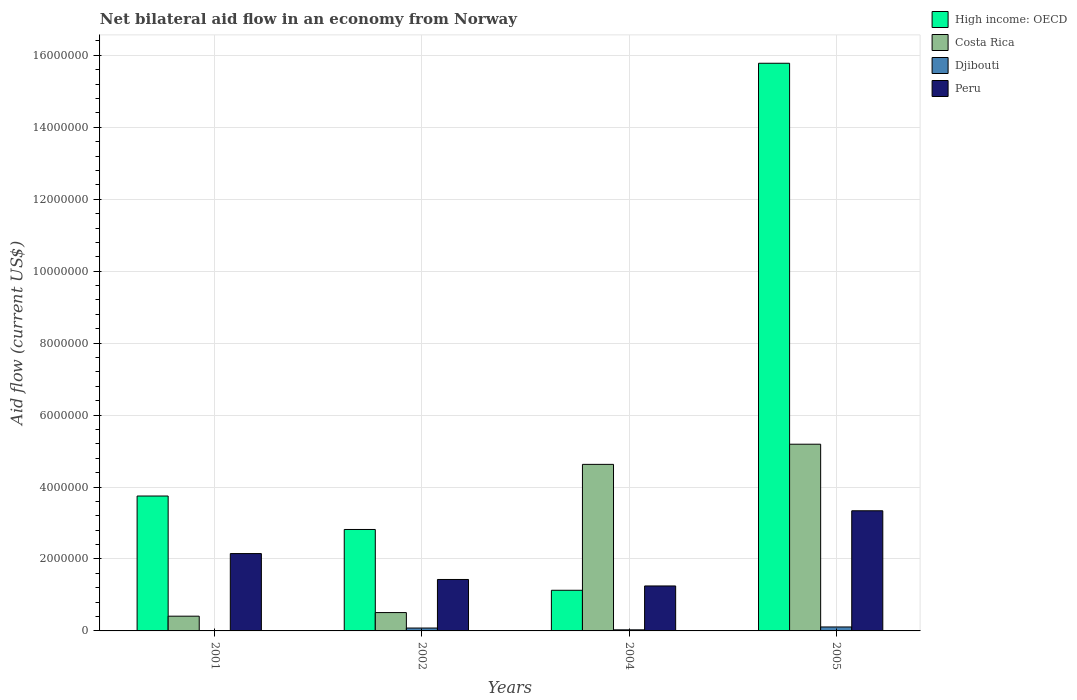How many different coloured bars are there?
Keep it short and to the point. 4. Are the number of bars per tick equal to the number of legend labels?
Offer a terse response. Yes. Are the number of bars on each tick of the X-axis equal?
Give a very brief answer. Yes. What is the label of the 1st group of bars from the left?
Ensure brevity in your answer.  2001. In how many cases, is the number of bars for a given year not equal to the number of legend labels?
Keep it short and to the point. 0. What is the net bilateral aid flow in Costa Rica in 2004?
Offer a very short reply. 4.63e+06. Across all years, what is the maximum net bilateral aid flow in Peru?
Ensure brevity in your answer.  3.34e+06. Across all years, what is the minimum net bilateral aid flow in Peru?
Give a very brief answer. 1.25e+06. In which year was the net bilateral aid flow in Djibouti minimum?
Your answer should be very brief. 2001. What is the total net bilateral aid flow in Peru in the graph?
Provide a short and direct response. 8.17e+06. What is the difference between the net bilateral aid flow in Peru in 2001 and that in 2005?
Offer a terse response. -1.19e+06. What is the difference between the net bilateral aid flow in Costa Rica in 2001 and the net bilateral aid flow in Peru in 2004?
Your response must be concise. -8.40e+05. What is the average net bilateral aid flow in Djibouti per year?
Give a very brief answer. 5.75e+04. In the year 2001, what is the difference between the net bilateral aid flow in Peru and net bilateral aid flow in High income: OECD?
Your answer should be very brief. -1.60e+06. What is the ratio of the net bilateral aid flow in Costa Rica in 2002 to that in 2004?
Ensure brevity in your answer.  0.11. Is the net bilateral aid flow in Peru in 2002 less than that in 2004?
Ensure brevity in your answer.  No. Is the difference between the net bilateral aid flow in Peru in 2001 and 2004 greater than the difference between the net bilateral aid flow in High income: OECD in 2001 and 2004?
Provide a short and direct response. No. What is the difference between the highest and the second highest net bilateral aid flow in High income: OECD?
Offer a very short reply. 1.20e+07. What is the difference between the highest and the lowest net bilateral aid flow in Costa Rica?
Keep it short and to the point. 4.78e+06. In how many years, is the net bilateral aid flow in Peru greater than the average net bilateral aid flow in Peru taken over all years?
Provide a short and direct response. 2. Is the sum of the net bilateral aid flow in High income: OECD in 2001 and 2002 greater than the maximum net bilateral aid flow in Djibouti across all years?
Offer a terse response. Yes. What does the 1st bar from the left in 2005 represents?
Give a very brief answer. High income: OECD. What does the 4th bar from the right in 2002 represents?
Your answer should be very brief. High income: OECD. Is it the case that in every year, the sum of the net bilateral aid flow in Peru and net bilateral aid flow in High income: OECD is greater than the net bilateral aid flow in Costa Rica?
Give a very brief answer. No. How many bars are there?
Make the answer very short. 16. How many years are there in the graph?
Your answer should be very brief. 4. Does the graph contain any zero values?
Provide a succinct answer. No. Does the graph contain grids?
Keep it short and to the point. Yes. Where does the legend appear in the graph?
Offer a very short reply. Top right. How many legend labels are there?
Make the answer very short. 4. How are the legend labels stacked?
Your response must be concise. Vertical. What is the title of the graph?
Provide a short and direct response. Net bilateral aid flow in an economy from Norway. What is the label or title of the X-axis?
Provide a short and direct response. Years. What is the label or title of the Y-axis?
Give a very brief answer. Aid flow (current US$). What is the Aid flow (current US$) in High income: OECD in 2001?
Ensure brevity in your answer.  3.75e+06. What is the Aid flow (current US$) in Peru in 2001?
Your answer should be compact. 2.15e+06. What is the Aid flow (current US$) in High income: OECD in 2002?
Your answer should be compact. 2.82e+06. What is the Aid flow (current US$) of Costa Rica in 2002?
Offer a terse response. 5.10e+05. What is the Aid flow (current US$) of Peru in 2002?
Offer a terse response. 1.43e+06. What is the Aid flow (current US$) of High income: OECD in 2004?
Your answer should be very brief. 1.13e+06. What is the Aid flow (current US$) in Costa Rica in 2004?
Provide a short and direct response. 4.63e+06. What is the Aid flow (current US$) of Djibouti in 2004?
Provide a short and direct response. 3.00e+04. What is the Aid flow (current US$) of Peru in 2004?
Provide a short and direct response. 1.25e+06. What is the Aid flow (current US$) of High income: OECD in 2005?
Offer a very short reply. 1.58e+07. What is the Aid flow (current US$) in Costa Rica in 2005?
Ensure brevity in your answer.  5.19e+06. What is the Aid flow (current US$) of Djibouti in 2005?
Keep it short and to the point. 1.10e+05. What is the Aid flow (current US$) of Peru in 2005?
Give a very brief answer. 3.34e+06. Across all years, what is the maximum Aid flow (current US$) of High income: OECD?
Offer a very short reply. 1.58e+07. Across all years, what is the maximum Aid flow (current US$) of Costa Rica?
Your answer should be very brief. 5.19e+06. Across all years, what is the maximum Aid flow (current US$) in Djibouti?
Ensure brevity in your answer.  1.10e+05. Across all years, what is the maximum Aid flow (current US$) of Peru?
Keep it short and to the point. 3.34e+06. Across all years, what is the minimum Aid flow (current US$) of High income: OECD?
Ensure brevity in your answer.  1.13e+06. Across all years, what is the minimum Aid flow (current US$) of Costa Rica?
Keep it short and to the point. 4.10e+05. Across all years, what is the minimum Aid flow (current US$) of Peru?
Your answer should be compact. 1.25e+06. What is the total Aid flow (current US$) in High income: OECD in the graph?
Keep it short and to the point. 2.35e+07. What is the total Aid flow (current US$) in Costa Rica in the graph?
Ensure brevity in your answer.  1.07e+07. What is the total Aid flow (current US$) in Djibouti in the graph?
Your answer should be very brief. 2.30e+05. What is the total Aid flow (current US$) in Peru in the graph?
Provide a succinct answer. 8.17e+06. What is the difference between the Aid flow (current US$) of High income: OECD in 2001 and that in 2002?
Ensure brevity in your answer.  9.30e+05. What is the difference between the Aid flow (current US$) of Costa Rica in 2001 and that in 2002?
Provide a succinct answer. -1.00e+05. What is the difference between the Aid flow (current US$) of Peru in 2001 and that in 2002?
Keep it short and to the point. 7.20e+05. What is the difference between the Aid flow (current US$) of High income: OECD in 2001 and that in 2004?
Keep it short and to the point. 2.62e+06. What is the difference between the Aid flow (current US$) of Costa Rica in 2001 and that in 2004?
Offer a very short reply. -4.22e+06. What is the difference between the Aid flow (current US$) in Peru in 2001 and that in 2004?
Ensure brevity in your answer.  9.00e+05. What is the difference between the Aid flow (current US$) in High income: OECD in 2001 and that in 2005?
Ensure brevity in your answer.  -1.20e+07. What is the difference between the Aid flow (current US$) of Costa Rica in 2001 and that in 2005?
Ensure brevity in your answer.  -4.78e+06. What is the difference between the Aid flow (current US$) in Djibouti in 2001 and that in 2005?
Offer a very short reply. -1.00e+05. What is the difference between the Aid flow (current US$) in Peru in 2001 and that in 2005?
Provide a short and direct response. -1.19e+06. What is the difference between the Aid flow (current US$) of High income: OECD in 2002 and that in 2004?
Provide a succinct answer. 1.69e+06. What is the difference between the Aid flow (current US$) of Costa Rica in 2002 and that in 2004?
Keep it short and to the point. -4.12e+06. What is the difference between the Aid flow (current US$) of Peru in 2002 and that in 2004?
Offer a very short reply. 1.80e+05. What is the difference between the Aid flow (current US$) in High income: OECD in 2002 and that in 2005?
Ensure brevity in your answer.  -1.30e+07. What is the difference between the Aid flow (current US$) of Costa Rica in 2002 and that in 2005?
Provide a succinct answer. -4.68e+06. What is the difference between the Aid flow (current US$) in Djibouti in 2002 and that in 2005?
Give a very brief answer. -3.00e+04. What is the difference between the Aid flow (current US$) of Peru in 2002 and that in 2005?
Your answer should be very brief. -1.91e+06. What is the difference between the Aid flow (current US$) of High income: OECD in 2004 and that in 2005?
Your response must be concise. -1.46e+07. What is the difference between the Aid flow (current US$) in Costa Rica in 2004 and that in 2005?
Your response must be concise. -5.60e+05. What is the difference between the Aid flow (current US$) of Peru in 2004 and that in 2005?
Offer a very short reply. -2.09e+06. What is the difference between the Aid flow (current US$) of High income: OECD in 2001 and the Aid flow (current US$) of Costa Rica in 2002?
Your answer should be compact. 3.24e+06. What is the difference between the Aid flow (current US$) of High income: OECD in 2001 and the Aid flow (current US$) of Djibouti in 2002?
Provide a succinct answer. 3.67e+06. What is the difference between the Aid flow (current US$) of High income: OECD in 2001 and the Aid flow (current US$) of Peru in 2002?
Offer a very short reply. 2.32e+06. What is the difference between the Aid flow (current US$) of Costa Rica in 2001 and the Aid flow (current US$) of Peru in 2002?
Keep it short and to the point. -1.02e+06. What is the difference between the Aid flow (current US$) of Djibouti in 2001 and the Aid flow (current US$) of Peru in 2002?
Offer a terse response. -1.42e+06. What is the difference between the Aid flow (current US$) of High income: OECD in 2001 and the Aid flow (current US$) of Costa Rica in 2004?
Provide a short and direct response. -8.80e+05. What is the difference between the Aid flow (current US$) in High income: OECD in 2001 and the Aid flow (current US$) in Djibouti in 2004?
Keep it short and to the point. 3.72e+06. What is the difference between the Aid flow (current US$) in High income: OECD in 2001 and the Aid flow (current US$) in Peru in 2004?
Give a very brief answer. 2.50e+06. What is the difference between the Aid flow (current US$) of Costa Rica in 2001 and the Aid flow (current US$) of Peru in 2004?
Your response must be concise. -8.40e+05. What is the difference between the Aid flow (current US$) of Djibouti in 2001 and the Aid flow (current US$) of Peru in 2004?
Give a very brief answer. -1.24e+06. What is the difference between the Aid flow (current US$) of High income: OECD in 2001 and the Aid flow (current US$) of Costa Rica in 2005?
Your response must be concise. -1.44e+06. What is the difference between the Aid flow (current US$) in High income: OECD in 2001 and the Aid flow (current US$) in Djibouti in 2005?
Offer a very short reply. 3.64e+06. What is the difference between the Aid flow (current US$) in High income: OECD in 2001 and the Aid flow (current US$) in Peru in 2005?
Provide a short and direct response. 4.10e+05. What is the difference between the Aid flow (current US$) in Costa Rica in 2001 and the Aid flow (current US$) in Peru in 2005?
Offer a terse response. -2.93e+06. What is the difference between the Aid flow (current US$) of Djibouti in 2001 and the Aid flow (current US$) of Peru in 2005?
Give a very brief answer. -3.33e+06. What is the difference between the Aid flow (current US$) in High income: OECD in 2002 and the Aid flow (current US$) in Costa Rica in 2004?
Your response must be concise. -1.81e+06. What is the difference between the Aid flow (current US$) of High income: OECD in 2002 and the Aid flow (current US$) of Djibouti in 2004?
Make the answer very short. 2.79e+06. What is the difference between the Aid flow (current US$) of High income: OECD in 2002 and the Aid flow (current US$) of Peru in 2004?
Your response must be concise. 1.57e+06. What is the difference between the Aid flow (current US$) of Costa Rica in 2002 and the Aid flow (current US$) of Peru in 2004?
Keep it short and to the point. -7.40e+05. What is the difference between the Aid flow (current US$) of Djibouti in 2002 and the Aid flow (current US$) of Peru in 2004?
Your response must be concise. -1.17e+06. What is the difference between the Aid flow (current US$) in High income: OECD in 2002 and the Aid flow (current US$) in Costa Rica in 2005?
Provide a short and direct response. -2.37e+06. What is the difference between the Aid flow (current US$) in High income: OECD in 2002 and the Aid flow (current US$) in Djibouti in 2005?
Your answer should be very brief. 2.71e+06. What is the difference between the Aid flow (current US$) in High income: OECD in 2002 and the Aid flow (current US$) in Peru in 2005?
Make the answer very short. -5.20e+05. What is the difference between the Aid flow (current US$) of Costa Rica in 2002 and the Aid flow (current US$) of Peru in 2005?
Provide a succinct answer. -2.83e+06. What is the difference between the Aid flow (current US$) in Djibouti in 2002 and the Aid flow (current US$) in Peru in 2005?
Offer a terse response. -3.26e+06. What is the difference between the Aid flow (current US$) in High income: OECD in 2004 and the Aid flow (current US$) in Costa Rica in 2005?
Your response must be concise. -4.06e+06. What is the difference between the Aid flow (current US$) in High income: OECD in 2004 and the Aid flow (current US$) in Djibouti in 2005?
Ensure brevity in your answer.  1.02e+06. What is the difference between the Aid flow (current US$) in High income: OECD in 2004 and the Aid flow (current US$) in Peru in 2005?
Make the answer very short. -2.21e+06. What is the difference between the Aid flow (current US$) in Costa Rica in 2004 and the Aid flow (current US$) in Djibouti in 2005?
Keep it short and to the point. 4.52e+06. What is the difference between the Aid flow (current US$) of Costa Rica in 2004 and the Aid flow (current US$) of Peru in 2005?
Provide a short and direct response. 1.29e+06. What is the difference between the Aid flow (current US$) of Djibouti in 2004 and the Aid flow (current US$) of Peru in 2005?
Ensure brevity in your answer.  -3.31e+06. What is the average Aid flow (current US$) in High income: OECD per year?
Keep it short and to the point. 5.87e+06. What is the average Aid flow (current US$) in Costa Rica per year?
Offer a very short reply. 2.68e+06. What is the average Aid flow (current US$) in Djibouti per year?
Your answer should be compact. 5.75e+04. What is the average Aid flow (current US$) of Peru per year?
Offer a very short reply. 2.04e+06. In the year 2001, what is the difference between the Aid flow (current US$) in High income: OECD and Aid flow (current US$) in Costa Rica?
Offer a terse response. 3.34e+06. In the year 2001, what is the difference between the Aid flow (current US$) of High income: OECD and Aid flow (current US$) of Djibouti?
Keep it short and to the point. 3.74e+06. In the year 2001, what is the difference between the Aid flow (current US$) of High income: OECD and Aid flow (current US$) of Peru?
Provide a short and direct response. 1.60e+06. In the year 2001, what is the difference between the Aid flow (current US$) of Costa Rica and Aid flow (current US$) of Djibouti?
Ensure brevity in your answer.  4.00e+05. In the year 2001, what is the difference between the Aid flow (current US$) of Costa Rica and Aid flow (current US$) of Peru?
Offer a terse response. -1.74e+06. In the year 2001, what is the difference between the Aid flow (current US$) of Djibouti and Aid flow (current US$) of Peru?
Provide a succinct answer. -2.14e+06. In the year 2002, what is the difference between the Aid flow (current US$) of High income: OECD and Aid flow (current US$) of Costa Rica?
Your response must be concise. 2.31e+06. In the year 2002, what is the difference between the Aid flow (current US$) of High income: OECD and Aid flow (current US$) of Djibouti?
Offer a terse response. 2.74e+06. In the year 2002, what is the difference between the Aid flow (current US$) in High income: OECD and Aid flow (current US$) in Peru?
Keep it short and to the point. 1.39e+06. In the year 2002, what is the difference between the Aid flow (current US$) in Costa Rica and Aid flow (current US$) in Djibouti?
Make the answer very short. 4.30e+05. In the year 2002, what is the difference between the Aid flow (current US$) of Costa Rica and Aid flow (current US$) of Peru?
Offer a terse response. -9.20e+05. In the year 2002, what is the difference between the Aid flow (current US$) in Djibouti and Aid flow (current US$) in Peru?
Your response must be concise. -1.35e+06. In the year 2004, what is the difference between the Aid flow (current US$) of High income: OECD and Aid flow (current US$) of Costa Rica?
Your answer should be very brief. -3.50e+06. In the year 2004, what is the difference between the Aid flow (current US$) in High income: OECD and Aid flow (current US$) in Djibouti?
Give a very brief answer. 1.10e+06. In the year 2004, what is the difference between the Aid flow (current US$) of Costa Rica and Aid flow (current US$) of Djibouti?
Give a very brief answer. 4.60e+06. In the year 2004, what is the difference between the Aid flow (current US$) of Costa Rica and Aid flow (current US$) of Peru?
Make the answer very short. 3.38e+06. In the year 2004, what is the difference between the Aid flow (current US$) of Djibouti and Aid flow (current US$) of Peru?
Your answer should be very brief. -1.22e+06. In the year 2005, what is the difference between the Aid flow (current US$) of High income: OECD and Aid flow (current US$) of Costa Rica?
Give a very brief answer. 1.06e+07. In the year 2005, what is the difference between the Aid flow (current US$) of High income: OECD and Aid flow (current US$) of Djibouti?
Your answer should be compact. 1.57e+07. In the year 2005, what is the difference between the Aid flow (current US$) of High income: OECD and Aid flow (current US$) of Peru?
Your answer should be very brief. 1.24e+07. In the year 2005, what is the difference between the Aid flow (current US$) in Costa Rica and Aid flow (current US$) in Djibouti?
Your response must be concise. 5.08e+06. In the year 2005, what is the difference between the Aid flow (current US$) in Costa Rica and Aid flow (current US$) in Peru?
Your answer should be compact. 1.85e+06. In the year 2005, what is the difference between the Aid flow (current US$) in Djibouti and Aid flow (current US$) in Peru?
Offer a very short reply. -3.23e+06. What is the ratio of the Aid flow (current US$) of High income: OECD in 2001 to that in 2002?
Provide a succinct answer. 1.33. What is the ratio of the Aid flow (current US$) in Costa Rica in 2001 to that in 2002?
Keep it short and to the point. 0.8. What is the ratio of the Aid flow (current US$) of Djibouti in 2001 to that in 2002?
Provide a succinct answer. 0.12. What is the ratio of the Aid flow (current US$) in Peru in 2001 to that in 2002?
Keep it short and to the point. 1.5. What is the ratio of the Aid flow (current US$) in High income: OECD in 2001 to that in 2004?
Give a very brief answer. 3.32. What is the ratio of the Aid flow (current US$) of Costa Rica in 2001 to that in 2004?
Keep it short and to the point. 0.09. What is the ratio of the Aid flow (current US$) of Peru in 2001 to that in 2004?
Provide a succinct answer. 1.72. What is the ratio of the Aid flow (current US$) of High income: OECD in 2001 to that in 2005?
Give a very brief answer. 0.24. What is the ratio of the Aid flow (current US$) of Costa Rica in 2001 to that in 2005?
Provide a short and direct response. 0.08. What is the ratio of the Aid flow (current US$) of Djibouti in 2001 to that in 2005?
Ensure brevity in your answer.  0.09. What is the ratio of the Aid flow (current US$) in Peru in 2001 to that in 2005?
Ensure brevity in your answer.  0.64. What is the ratio of the Aid flow (current US$) of High income: OECD in 2002 to that in 2004?
Your answer should be compact. 2.5. What is the ratio of the Aid flow (current US$) of Costa Rica in 2002 to that in 2004?
Your answer should be very brief. 0.11. What is the ratio of the Aid flow (current US$) in Djibouti in 2002 to that in 2004?
Provide a succinct answer. 2.67. What is the ratio of the Aid flow (current US$) in Peru in 2002 to that in 2004?
Offer a very short reply. 1.14. What is the ratio of the Aid flow (current US$) in High income: OECD in 2002 to that in 2005?
Give a very brief answer. 0.18. What is the ratio of the Aid flow (current US$) in Costa Rica in 2002 to that in 2005?
Provide a short and direct response. 0.1. What is the ratio of the Aid flow (current US$) in Djibouti in 2002 to that in 2005?
Keep it short and to the point. 0.73. What is the ratio of the Aid flow (current US$) in Peru in 2002 to that in 2005?
Your answer should be very brief. 0.43. What is the ratio of the Aid flow (current US$) in High income: OECD in 2004 to that in 2005?
Make the answer very short. 0.07. What is the ratio of the Aid flow (current US$) of Costa Rica in 2004 to that in 2005?
Your answer should be very brief. 0.89. What is the ratio of the Aid flow (current US$) in Djibouti in 2004 to that in 2005?
Keep it short and to the point. 0.27. What is the ratio of the Aid flow (current US$) of Peru in 2004 to that in 2005?
Offer a terse response. 0.37. What is the difference between the highest and the second highest Aid flow (current US$) in High income: OECD?
Give a very brief answer. 1.20e+07. What is the difference between the highest and the second highest Aid flow (current US$) in Costa Rica?
Offer a terse response. 5.60e+05. What is the difference between the highest and the second highest Aid flow (current US$) of Peru?
Offer a very short reply. 1.19e+06. What is the difference between the highest and the lowest Aid flow (current US$) of High income: OECD?
Provide a short and direct response. 1.46e+07. What is the difference between the highest and the lowest Aid flow (current US$) of Costa Rica?
Provide a succinct answer. 4.78e+06. What is the difference between the highest and the lowest Aid flow (current US$) in Djibouti?
Provide a short and direct response. 1.00e+05. What is the difference between the highest and the lowest Aid flow (current US$) of Peru?
Make the answer very short. 2.09e+06. 